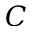<formula> <loc_0><loc_0><loc_500><loc_500>C</formula> 